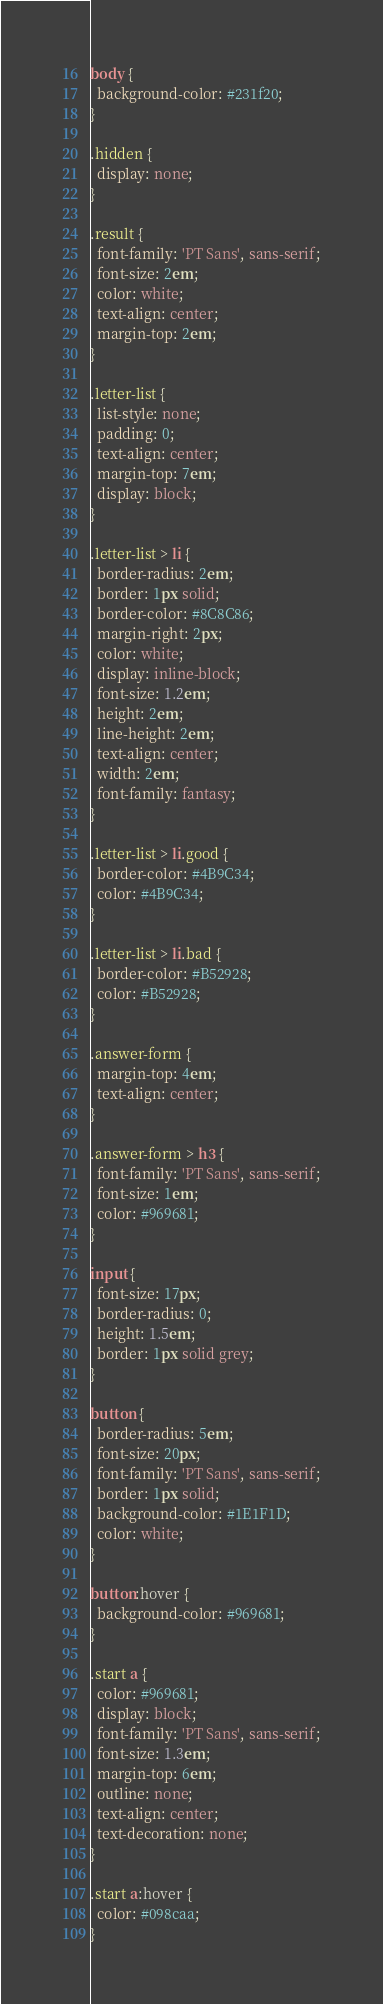Convert code to text. <code><loc_0><loc_0><loc_500><loc_500><_CSS_>body {
  background-color: #231f20;
}

.hidden {
  display: none;
}

.result {
  font-family: 'PT Sans', sans-serif;
  font-size: 2em;
  color: white;
  text-align: center;
  margin-top: 2em;
}

.letter-list {
  list-style: none;
  padding: 0;
  text-align: center;
  margin-top: 7em;
  display: block;
}

.letter-list > li {
  border-radius: 2em;
  border: 1px solid;
  border-color: #8C8C86;
  margin-right: 2px;
  color: white;
  display: inline-block;
  font-size: 1.2em;
  height: 2em;
  line-height: 2em;
  text-align: center;
  width: 2em;
  font-family: fantasy;
}

.letter-list > li.good {
  border-color: #4B9C34;
  color: #4B9C34;
}

.letter-list > li.bad {
  border-color: #B52928;
  color: #B52928;
}

.answer-form {
  margin-top: 4em;
  text-align: center;
}

.answer-form > h3 {
  font-family: 'PT Sans', sans-serif;
  font-size: 1em;
  color: #969681;
}

input {
  font-size: 17px;
  border-radius: 0;
  height: 1.5em;
  border: 1px solid grey;
}

button {
  border-radius: 5em;
  font-size: 20px;
  font-family: 'PT Sans', sans-serif;
  border: 1px solid;
  background-color: #1E1F1D;
  color: white;
}

button:hover {
  background-color: #969681;
}

.start a {
  color: #969681;
  display: block;
  font-family: 'PT Sans', sans-serif;
  font-size: 1.3em;
  margin-top: 6em;
  outline: none;
  text-align: center;
  text-decoration: none;
}

.start a:hover {
  color: #098caa;
}

</code> 